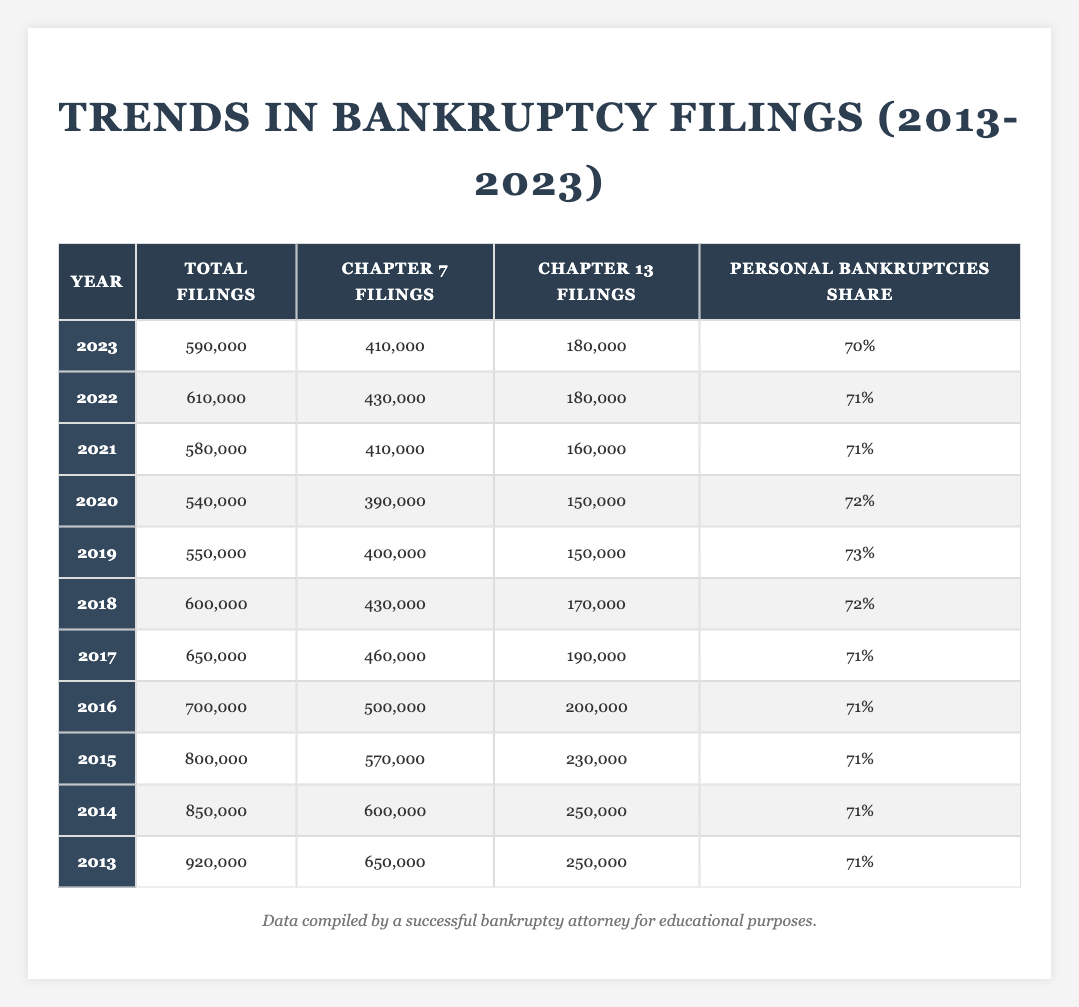What was the total number of bankruptcy filings in 2017? In the table under the year 2017, the total filings are listed as 650,000.
Answer: 650,000 Which year had the highest number of Chapter 7 filings? The year 2013 had the highest number of Chapter 7 filings at 650,000 as shown in the table.
Answer: 2013 What percentage of filings in 2022 were Chapter 13? For the year 2022, there were 180,000 Chapter 13 filings out of 610,000 total filings. To find the percentage, we calculate (180,000/610,000) * 100 = 29.51%.
Answer: 29.51% How many more Chapter 7 filings were there in 2014 compared to 2021? In 2014, Chapter 7 filings were 600,000, and in 2021, they were 410,000. The difference is 600,000 - 410,000 = 190,000.
Answer: 190,000 What trend do you observe in the total filings from 2013 to 2023? The total bankruptcy filings have decreased from 920,000 in 2013 to 590,000 in 2023, indicating a downward trend over the decade.
Answer: Downward trend In which year did the share of personal bankruptcies first drop below 71%? The share of personal bankruptcies dropped below 71% in the year 2023, where it is noted at 70%.
Answer: 2023 What was the difference in total filings between 2015 and 2016? The total filings in 2015 were 800,000 and in 2016 were 700,000. The difference is 800,000 - 700,000 = 100,000.
Answer: 100,000 Which years saw an increase in total filings compared to the previous year? Analyzing the data, the years 2021 and 2022 show increases (580,000 in 2021 to 610,000 in 2022). No other year had an increase compared to the prior year in the decade.
Answer: 2021 to 2022 Calculate the average total filings over the decade (2013-2023). To find the average total filings, sum all the total filings from each year and divide by the number of years: (920,000 + 850,000 + 800,000 + 700,000 + 650,000 + 600,000 + 550,000 + 540,000 + 580,000 + 610,000 + 590,000) = 6,530,000, and 6,530,000/11 = approximately 593,636.
Answer: 593,636 Was there a year when Chapter 13 filings exceeded Chapter 7 filings? No, throughout the entire data range, Chapter 13 filings never exceeded Chapter 7 filings.
Answer: No 